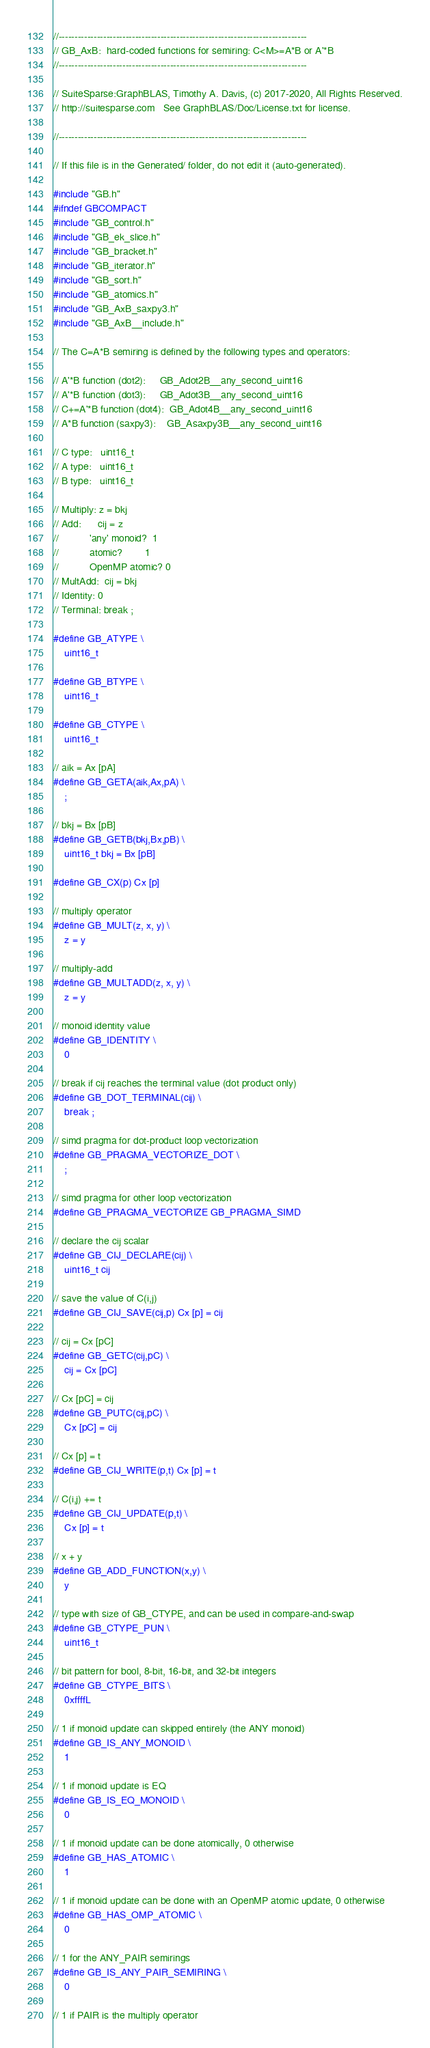<code> <loc_0><loc_0><loc_500><loc_500><_C_>//------------------------------------------------------------------------------
// GB_AxB:  hard-coded functions for semiring: C<M>=A*B or A'*B
//------------------------------------------------------------------------------

// SuiteSparse:GraphBLAS, Timothy A. Davis, (c) 2017-2020, All Rights Reserved.
// http://suitesparse.com   See GraphBLAS/Doc/License.txt for license.

//------------------------------------------------------------------------------

// If this file is in the Generated/ folder, do not edit it (auto-generated).

#include "GB.h"
#ifndef GBCOMPACT
#include "GB_control.h"
#include "GB_ek_slice.h"
#include "GB_bracket.h"
#include "GB_iterator.h"
#include "GB_sort.h"
#include "GB_atomics.h"
#include "GB_AxB_saxpy3.h"
#include "GB_AxB__include.h"

// The C=A*B semiring is defined by the following types and operators:

// A'*B function (dot2):     GB_Adot2B__any_second_uint16
// A'*B function (dot3):     GB_Adot3B__any_second_uint16
// C+=A'*B function (dot4):  GB_Adot4B__any_second_uint16
// A*B function (saxpy3):    GB_Asaxpy3B__any_second_uint16

// C type:   uint16_t
// A type:   uint16_t
// B type:   uint16_t

// Multiply: z = bkj
// Add:      cij = z
//           'any' monoid?  1
//           atomic?        1
//           OpenMP atomic? 0
// MultAdd:  cij = bkj
// Identity: 0
// Terminal: break ;

#define GB_ATYPE \
    uint16_t

#define GB_BTYPE \
    uint16_t

#define GB_CTYPE \
    uint16_t

// aik = Ax [pA]
#define GB_GETA(aik,Ax,pA) \
    ;

// bkj = Bx [pB]
#define GB_GETB(bkj,Bx,pB) \
    uint16_t bkj = Bx [pB]

#define GB_CX(p) Cx [p]

// multiply operator
#define GB_MULT(z, x, y) \
    z = y

// multiply-add
#define GB_MULTADD(z, x, y) \
    z = y

// monoid identity value
#define GB_IDENTITY \
    0

// break if cij reaches the terminal value (dot product only)
#define GB_DOT_TERMINAL(cij) \
    break ;

// simd pragma for dot-product loop vectorization
#define GB_PRAGMA_VECTORIZE_DOT \
    ;

// simd pragma for other loop vectorization
#define GB_PRAGMA_VECTORIZE GB_PRAGMA_SIMD

// declare the cij scalar
#define GB_CIJ_DECLARE(cij) \
    uint16_t cij

// save the value of C(i,j)
#define GB_CIJ_SAVE(cij,p) Cx [p] = cij

// cij = Cx [pC]
#define GB_GETC(cij,pC) \
    cij = Cx [pC]

// Cx [pC] = cij
#define GB_PUTC(cij,pC) \
    Cx [pC] = cij

// Cx [p] = t
#define GB_CIJ_WRITE(p,t) Cx [p] = t

// C(i,j) += t
#define GB_CIJ_UPDATE(p,t) \
    Cx [p] = t

// x + y
#define GB_ADD_FUNCTION(x,y) \
    y

// type with size of GB_CTYPE, and can be used in compare-and-swap
#define GB_CTYPE_PUN \
    uint16_t

// bit pattern for bool, 8-bit, 16-bit, and 32-bit integers
#define GB_CTYPE_BITS \
    0xffffL

// 1 if monoid update can skipped entirely (the ANY monoid)
#define GB_IS_ANY_MONOID \
    1

// 1 if monoid update is EQ
#define GB_IS_EQ_MONOID \
    0

// 1 if monoid update can be done atomically, 0 otherwise
#define GB_HAS_ATOMIC \
    1

// 1 if monoid update can be done with an OpenMP atomic update, 0 otherwise
#define GB_HAS_OMP_ATOMIC \
    0

// 1 for the ANY_PAIR semirings
#define GB_IS_ANY_PAIR_SEMIRING \
    0

// 1 if PAIR is the multiply operator </code> 